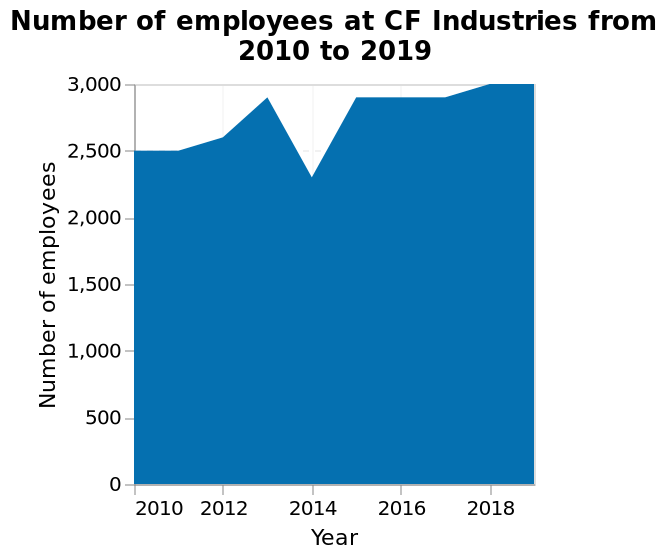<image>
How many employees did CF Industries have in 2010? CF Industries had 2500 employees in 2010. please describe the details of the chart This is a area diagram labeled Number of employees at CF Industries from 2010 to 2019. The x-axis measures Year while the y-axis measures Number of employees. What is the time period covered by the area diagram?  The area diagram covers the years from 2010 to 2019. 